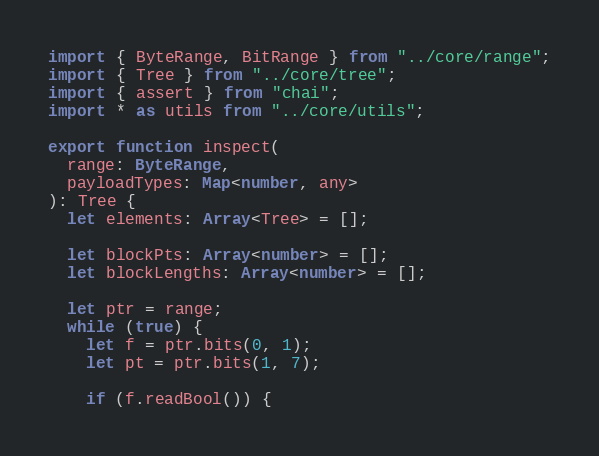<code> <loc_0><loc_0><loc_500><loc_500><_TypeScript_>import { ByteRange, BitRange } from "../core/range";
import { Tree } from "../core/tree";
import { assert } from "chai";
import * as utils from "../core/utils";

export function inspect(
  range: ByteRange,
  payloadTypes: Map<number, any>
): Tree {
  let elements: Array<Tree> = [];

  let blockPts: Array<number> = [];
  let blockLengths: Array<number> = [];

  let ptr = range;
  while (true) {
    let f = ptr.bits(0, 1);
    let pt = ptr.bits(1, 7);

    if (f.readBool()) {</code> 